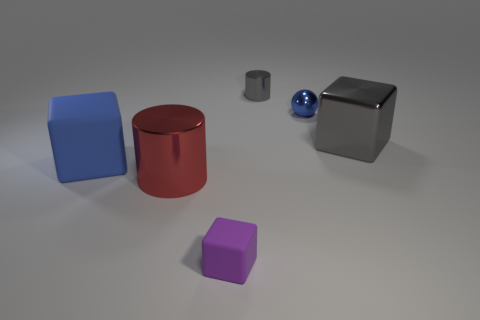Subtract all green cylinders. Subtract all cyan blocks. How many cylinders are left? 2 Add 3 tiny blue cubes. How many objects exist? 9 Subtract all cylinders. How many objects are left? 4 Subtract 0 red blocks. How many objects are left? 6 Subtract all blue blocks. Subtract all small gray shiny objects. How many objects are left? 4 Add 5 purple matte cubes. How many purple matte cubes are left? 6 Add 6 rubber blocks. How many rubber blocks exist? 8 